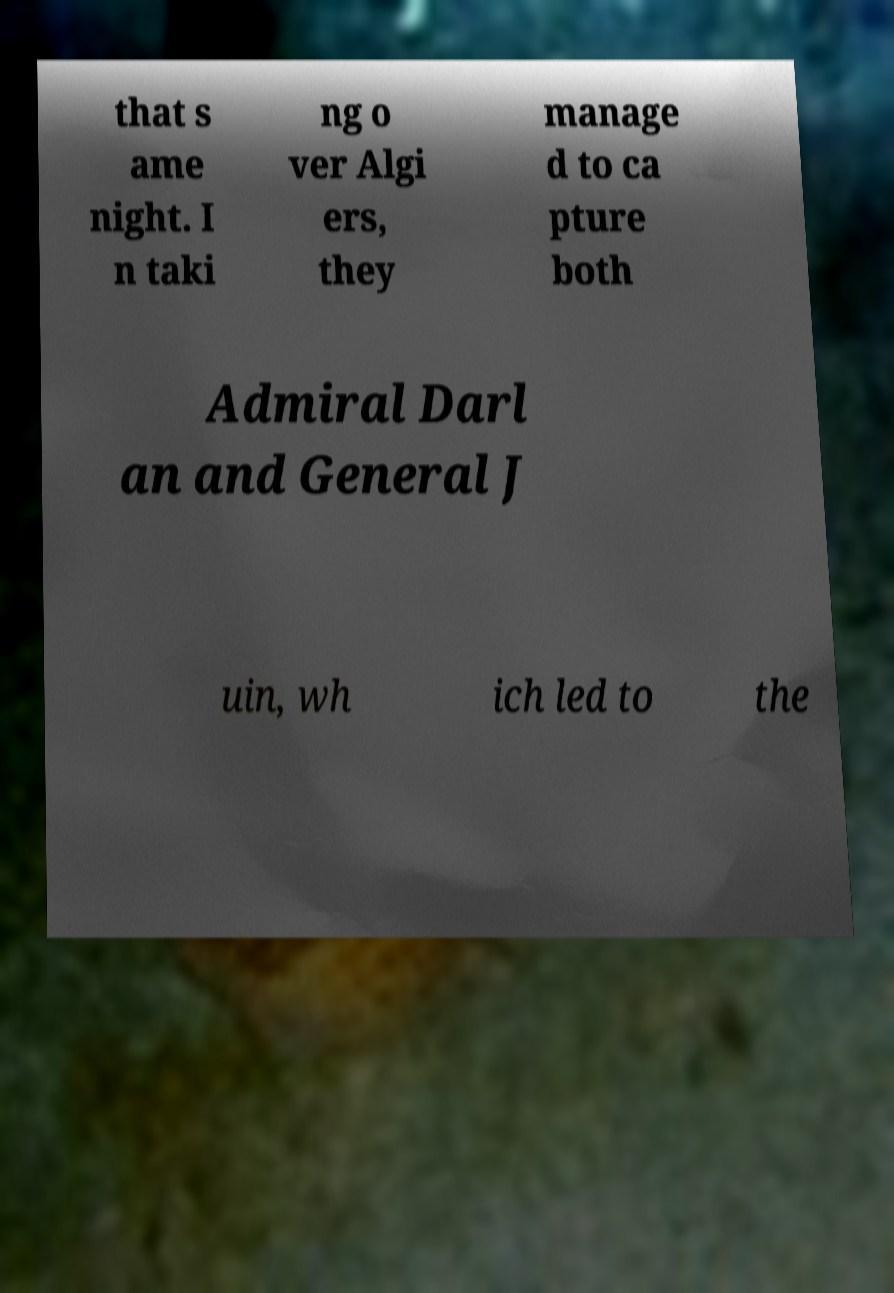Could you extract and type out the text from this image? that s ame night. I n taki ng o ver Algi ers, they manage d to ca pture both Admiral Darl an and General J uin, wh ich led to the 